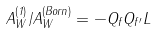Convert formula to latex. <formula><loc_0><loc_0><loc_500><loc_500>A _ { W } ^ { ( 1 ) } / A _ { W } ^ { ( B o r n ) } = - Q _ { f } Q _ { f ^ { \prime } } L</formula> 